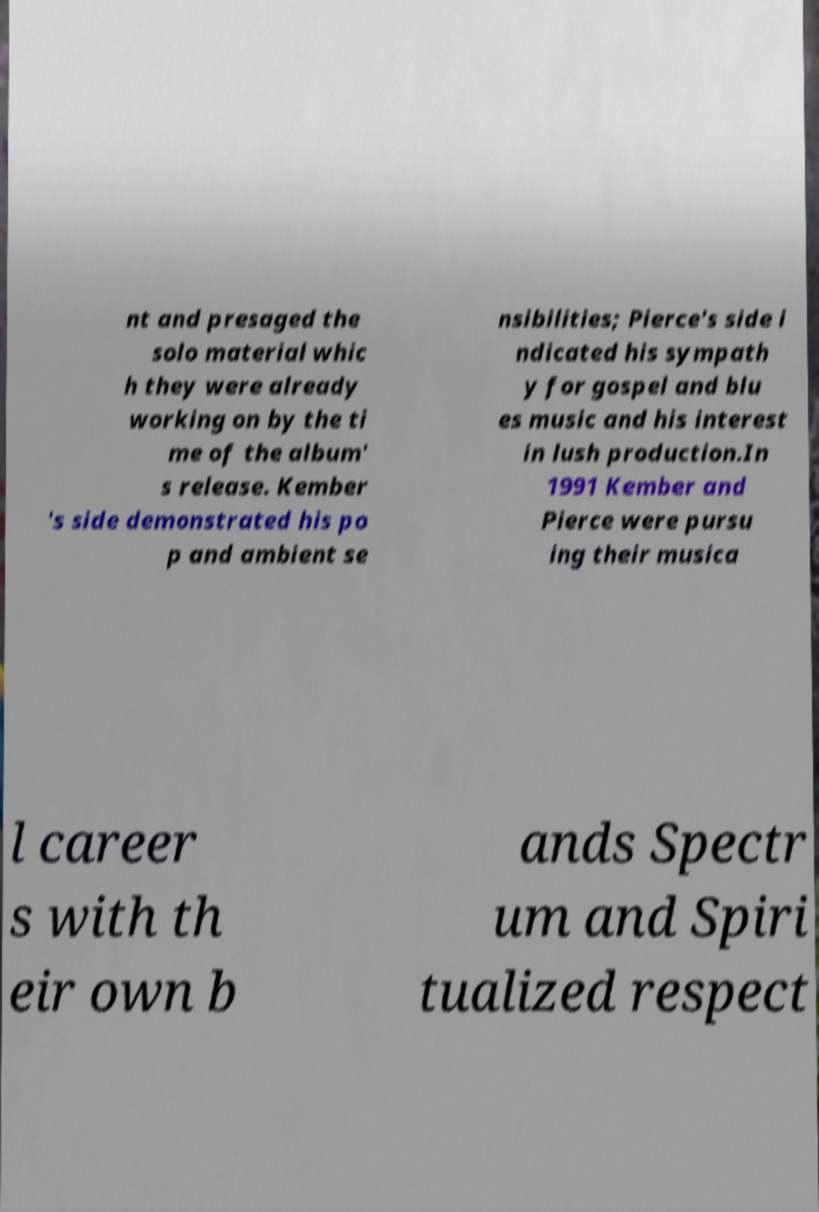Can you read and provide the text displayed in the image?This photo seems to have some interesting text. Can you extract and type it out for me? nt and presaged the solo material whic h they were already working on by the ti me of the album' s release. Kember 's side demonstrated his po p and ambient se nsibilities; Pierce's side i ndicated his sympath y for gospel and blu es music and his interest in lush production.In 1991 Kember and Pierce were pursu ing their musica l career s with th eir own b ands Spectr um and Spiri tualized respect 